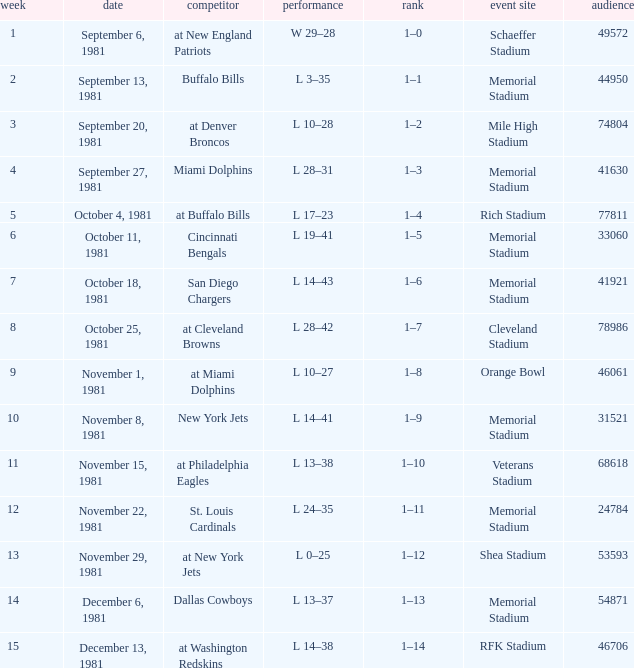When it is week 2 what is the record? 1–1. 